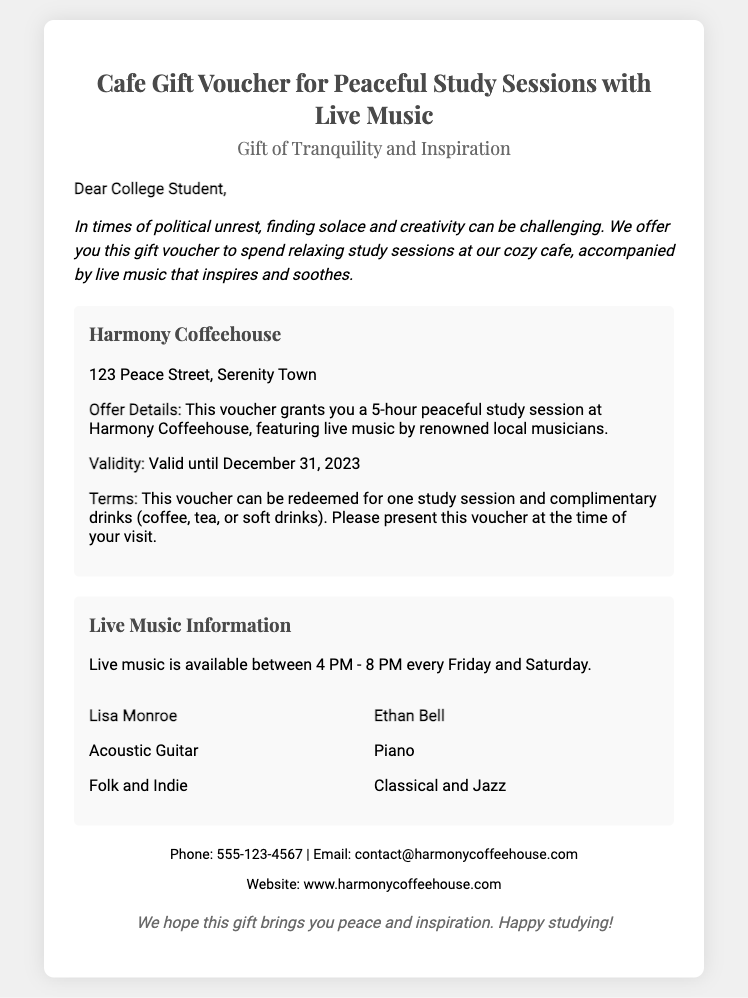What is the name of the cafe? The name of the cafe is mentioned as "Harmony Coffeehouse" in the document.
Answer: Harmony Coffeehouse What is the address of the cafe? The address provided in the document is where the cafe is located, which is "123 Peace Street, Serenity Town."
Answer: 123 Peace Street, Serenity Town How many hours does the voucher grant for a study session? The voucher specifies that it grants "5-hour peaceful study session."
Answer: 5 hours When does live music occur at the cafe? The document states that live music is available "between 4 PM - 8 PM every Friday and Saturday."
Answer: 4 PM - 8 PM every Friday and Saturday Who is the acoustic guitar artist performing? The document highlights the artist performing acoustic guitar, which is "Lisa Monroe."
Answer: Lisa Monroe What type of music does Ethan Bell play? The document mentions that Ethan Bell plays "Classical and Jazz" music.
Answer: Classical and Jazz What is the validity date of the voucher? The voucher states its validity period, which is "valid until December 31, 2023."
Answer: December 31, 2023 What drinks are included with the voucher? The document mentions that the voucher includes "complimentary drinks" such as coffee, tea, or soft drinks.
Answer: Coffee, tea, or soft drinks What is emphasized in the message to the recipient? The message emphasizes finding "solace and creativity" during difficult times such as political unrest.
Answer: Solace and creativity 